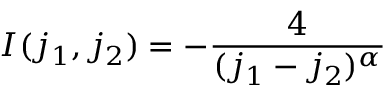<formula> <loc_0><loc_0><loc_500><loc_500>I ( j _ { 1 } , j _ { 2 } ) = - \frac { 4 } { ( j _ { 1 } - j _ { 2 } ) ^ { \alpha } }</formula> 